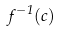Convert formula to latex. <formula><loc_0><loc_0><loc_500><loc_500>f ^ { - 1 } ( c )</formula> 